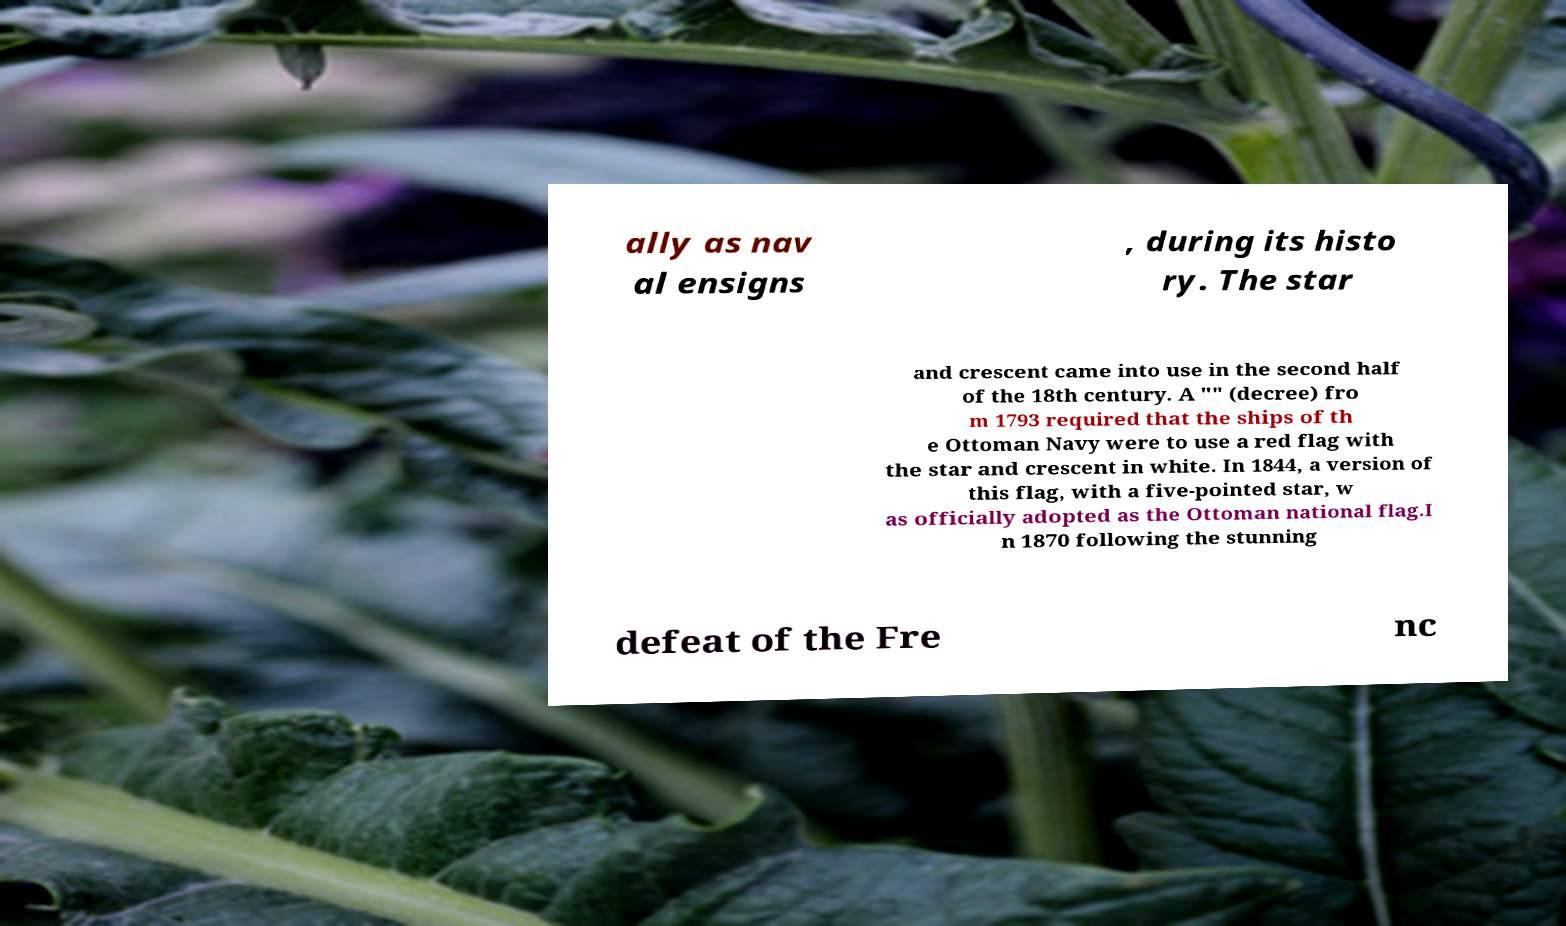I need the written content from this picture converted into text. Can you do that? ally as nav al ensigns , during its histo ry. The star and crescent came into use in the second half of the 18th century. A "" (decree) fro m 1793 required that the ships of th e Ottoman Navy were to use a red flag with the star and crescent in white. In 1844, a version of this flag, with a five-pointed star, w as officially adopted as the Ottoman national flag.I n 1870 following the stunning defeat of the Fre nc 